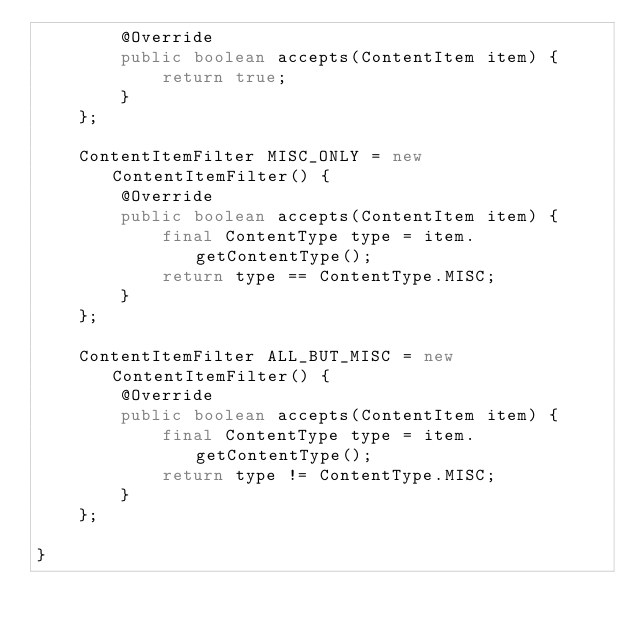<code> <loc_0><loc_0><loc_500><loc_500><_Java_>        @Override
        public boolean accepts(ContentItem item) {
            return true;
        }
    };

    ContentItemFilter MISC_ONLY = new ContentItemFilter() {
        @Override
        public boolean accepts(ContentItem item) {
            final ContentType type = item.getContentType();
            return type == ContentType.MISC;
        }
    };

    ContentItemFilter ALL_BUT_MISC = new ContentItemFilter() {
        @Override
        public boolean accepts(ContentItem item) {
            final ContentType type = item.getContentType();
            return type != ContentType.MISC;
        }
    };

}
</code> 